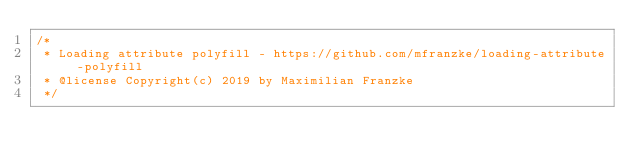<code> <loc_0><loc_0><loc_500><loc_500><_JavaScript_>/*
 * Loading attribute polyfill - https://github.com/mfranzke/loading-attribute-polyfill
 * @license Copyright(c) 2019 by Maximilian Franzke
 */</code> 